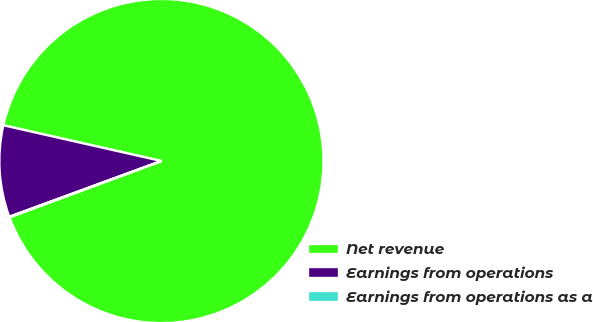<chart> <loc_0><loc_0><loc_500><loc_500><pie_chart><fcel>Net revenue<fcel>Earnings from operations<fcel>Earnings from operations as a<nl><fcel>90.81%<fcel>9.13%<fcel>0.06%<nl></chart> 